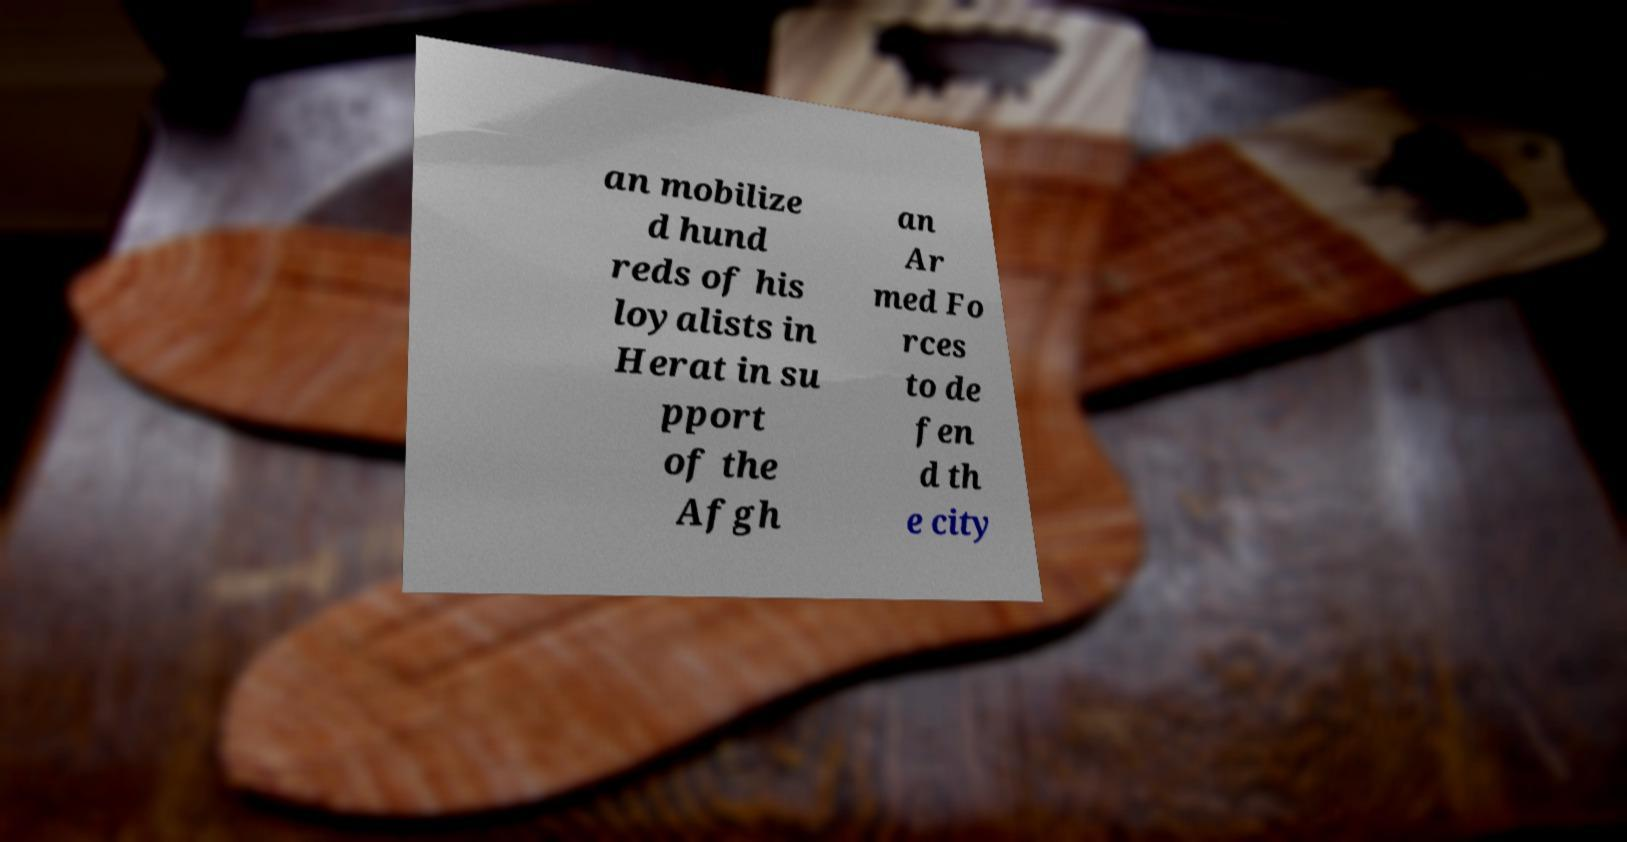Can you read and provide the text displayed in the image?This photo seems to have some interesting text. Can you extract and type it out for me? an mobilize d hund reds of his loyalists in Herat in su pport of the Afgh an Ar med Fo rces to de fen d th e city 